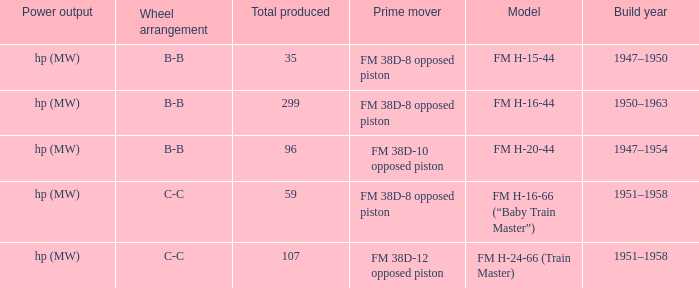Which is the smallest Total produced with a model of FM H-15-44? 35.0. 